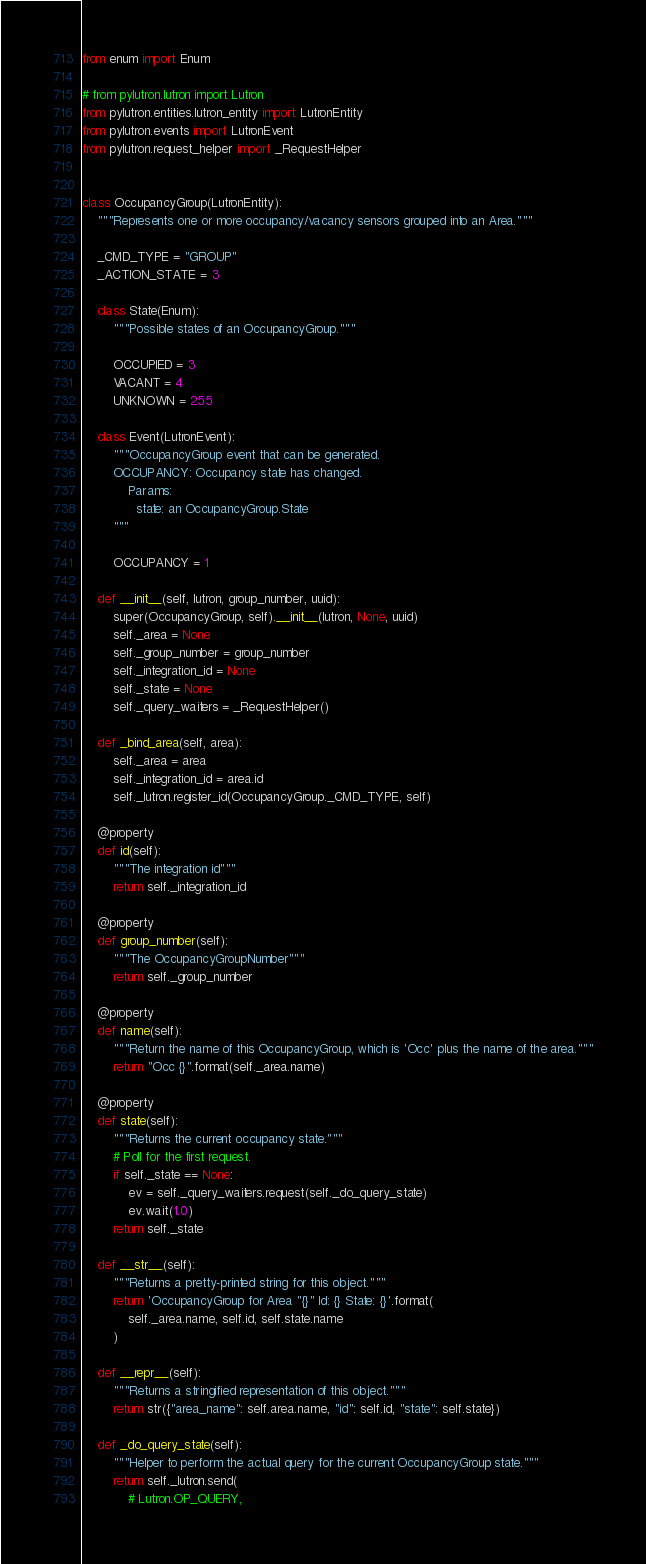<code> <loc_0><loc_0><loc_500><loc_500><_Python_>from enum import Enum

# from pylutron.lutron import Lutron
from pylutron.entities.lutron_entity import LutronEntity
from pylutron.events import LutronEvent
from pylutron.request_helper import _RequestHelper


class OccupancyGroup(LutronEntity):
    """Represents one or more occupancy/vacancy sensors grouped into an Area."""

    _CMD_TYPE = "GROUP"
    _ACTION_STATE = 3

    class State(Enum):
        """Possible states of an OccupancyGroup."""

        OCCUPIED = 3
        VACANT = 4
        UNKNOWN = 255

    class Event(LutronEvent):
        """OccupancyGroup event that can be generated.
        OCCUPANCY: Occupancy state has changed.
            Params:
              state: an OccupancyGroup.State
        """

        OCCUPANCY = 1

    def __init__(self, lutron, group_number, uuid):
        super(OccupancyGroup, self).__init__(lutron, None, uuid)
        self._area = None
        self._group_number = group_number
        self._integration_id = None
        self._state = None
        self._query_waiters = _RequestHelper()

    def _bind_area(self, area):
        self._area = area
        self._integration_id = area.id
        self._lutron.register_id(OccupancyGroup._CMD_TYPE, self)

    @property
    def id(self):
        """The integration id"""
        return self._integration_id

    @property
    def group_number(self):
        """The OccupancyGroupNumber"""
        return self._group_number

    @property
    def name(self):
        """Return the name of this OccupancyGroup, which is 'Occ' plus the name of the area."""
        return "Occ {}".format(self._area.name)

    @property
    def state(self):
        """Returns the current occupancy state."""
        # Poll for the first request.
        if self._state == None:
            ev = self._query_waiters.request(self._do_query_state)
            ev.wait(1.0)
        return self._state

    def __str__(self):
        """Returns a pretty-printed string for this object."""
        return 'OccupancyGroup for Area "{}" Id: {} State: {}'.format(
            self._area.name, self.id, self.state.name
        )

    def __repr__(self):
        """Returns a stringified representation of this object."""
        return str({"area_name": self.area.name, "id": self.id, "state": self.state})

    def _do_query_state(self):
        """Helper to perform the actual query for the current OccupancyGroup state."""
        return self._lutron.send(
            # Lutron.OP_QUERY,</code> 